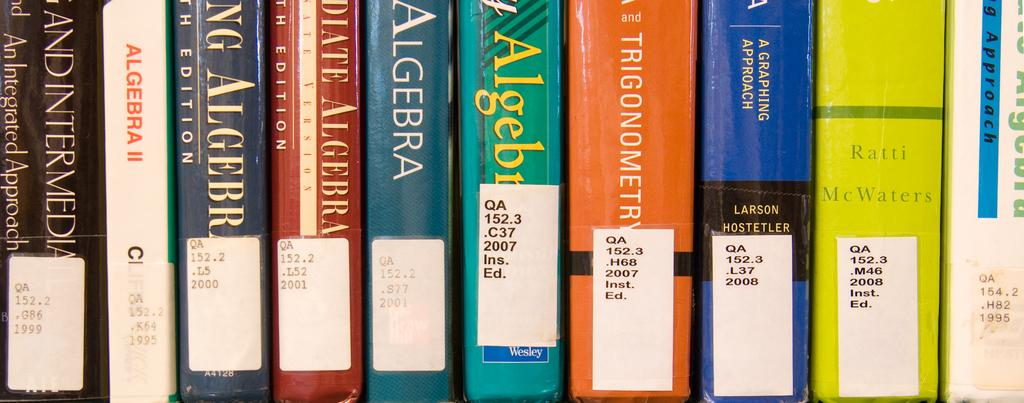<image>
Write a terse but informative summary of the picture. Different types of Algebra books on a shelf. 